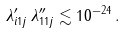Convert formula to latex. <formula><loc_0><loc_0><loc_500><loc_500>\lambda ^ { \prime } _ { i 1 j } \, \lambda ^ { \prime \prime } _ { 1 1 j } \lesssim 1 0 ^ { - 2 4 } \, .</formula> 